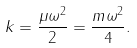Convert formula to latex. <formula><loc_0><loc_0><loc_500><loc_500>k = \frac { \mu \omega ^ { 2 } } { 2 } = \frac { m \omega ^ { 2 } } { 4 } .</formula> 